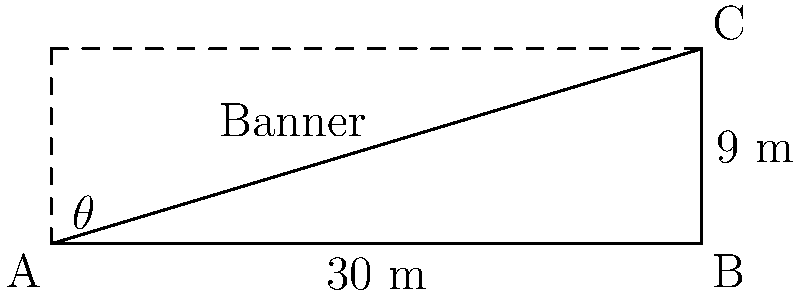For your upcoming concert to raise awareness against domestic violence, you want to hang a large banner between two poles. The poles are 30 meters apart, and the top of the shorter pole is 9 meters high. If the banner forms a 30° angle with the ground at the base of the shorter pole, what is the length of the banner to the nearest meter? Let's approach this step-by-step:

1) First, we can identify this as a right-angled triangle problem. The banner forms the hypotenuse of this triangle.

2) We know:
   - The distance between poles (base of triangle) is 30 m
   - The height of the shorter pole is 9 m
   - The angle at the base of the shorter pole is 30°

3) We need to find the length of the hypotenuse (the banner).

4) In a right-angled triangle, we can use the cosine ratio:

   $\cos \theta = \frac{\text{adjacent}}{\text{hypotenuse}}$

5) We know $\theta = 30°$, and the adjacent side is 30 m. Let's call the hypotenuse $x$:

   $\cos 30° = \frac{30}{x}$

6) We know that $\cos 30° = \frac{\sqrt{3}}{2}$. Substituting this:

   $\frac{\sqrt{3}}{2} = \frac{30}{x}$

7) Cross multiply:

   $x \cdot \frac{\sqrt{3}}{2} = 30$

8) Solve for $x$:

   $x = \frac{30}{\frac{\sqrt{3}}{2}} = \frac{30 \cdot 2}{\sqrt{3}} = \frac{60}{\sqrt{3}} = 20\sqrt{3} \approx 34.64$ m

9) Rounding to the nearest meter:

   $x \approx 35$ m

Therefore, the banner should be approximately 35 meters long.
Answer: 35 m 